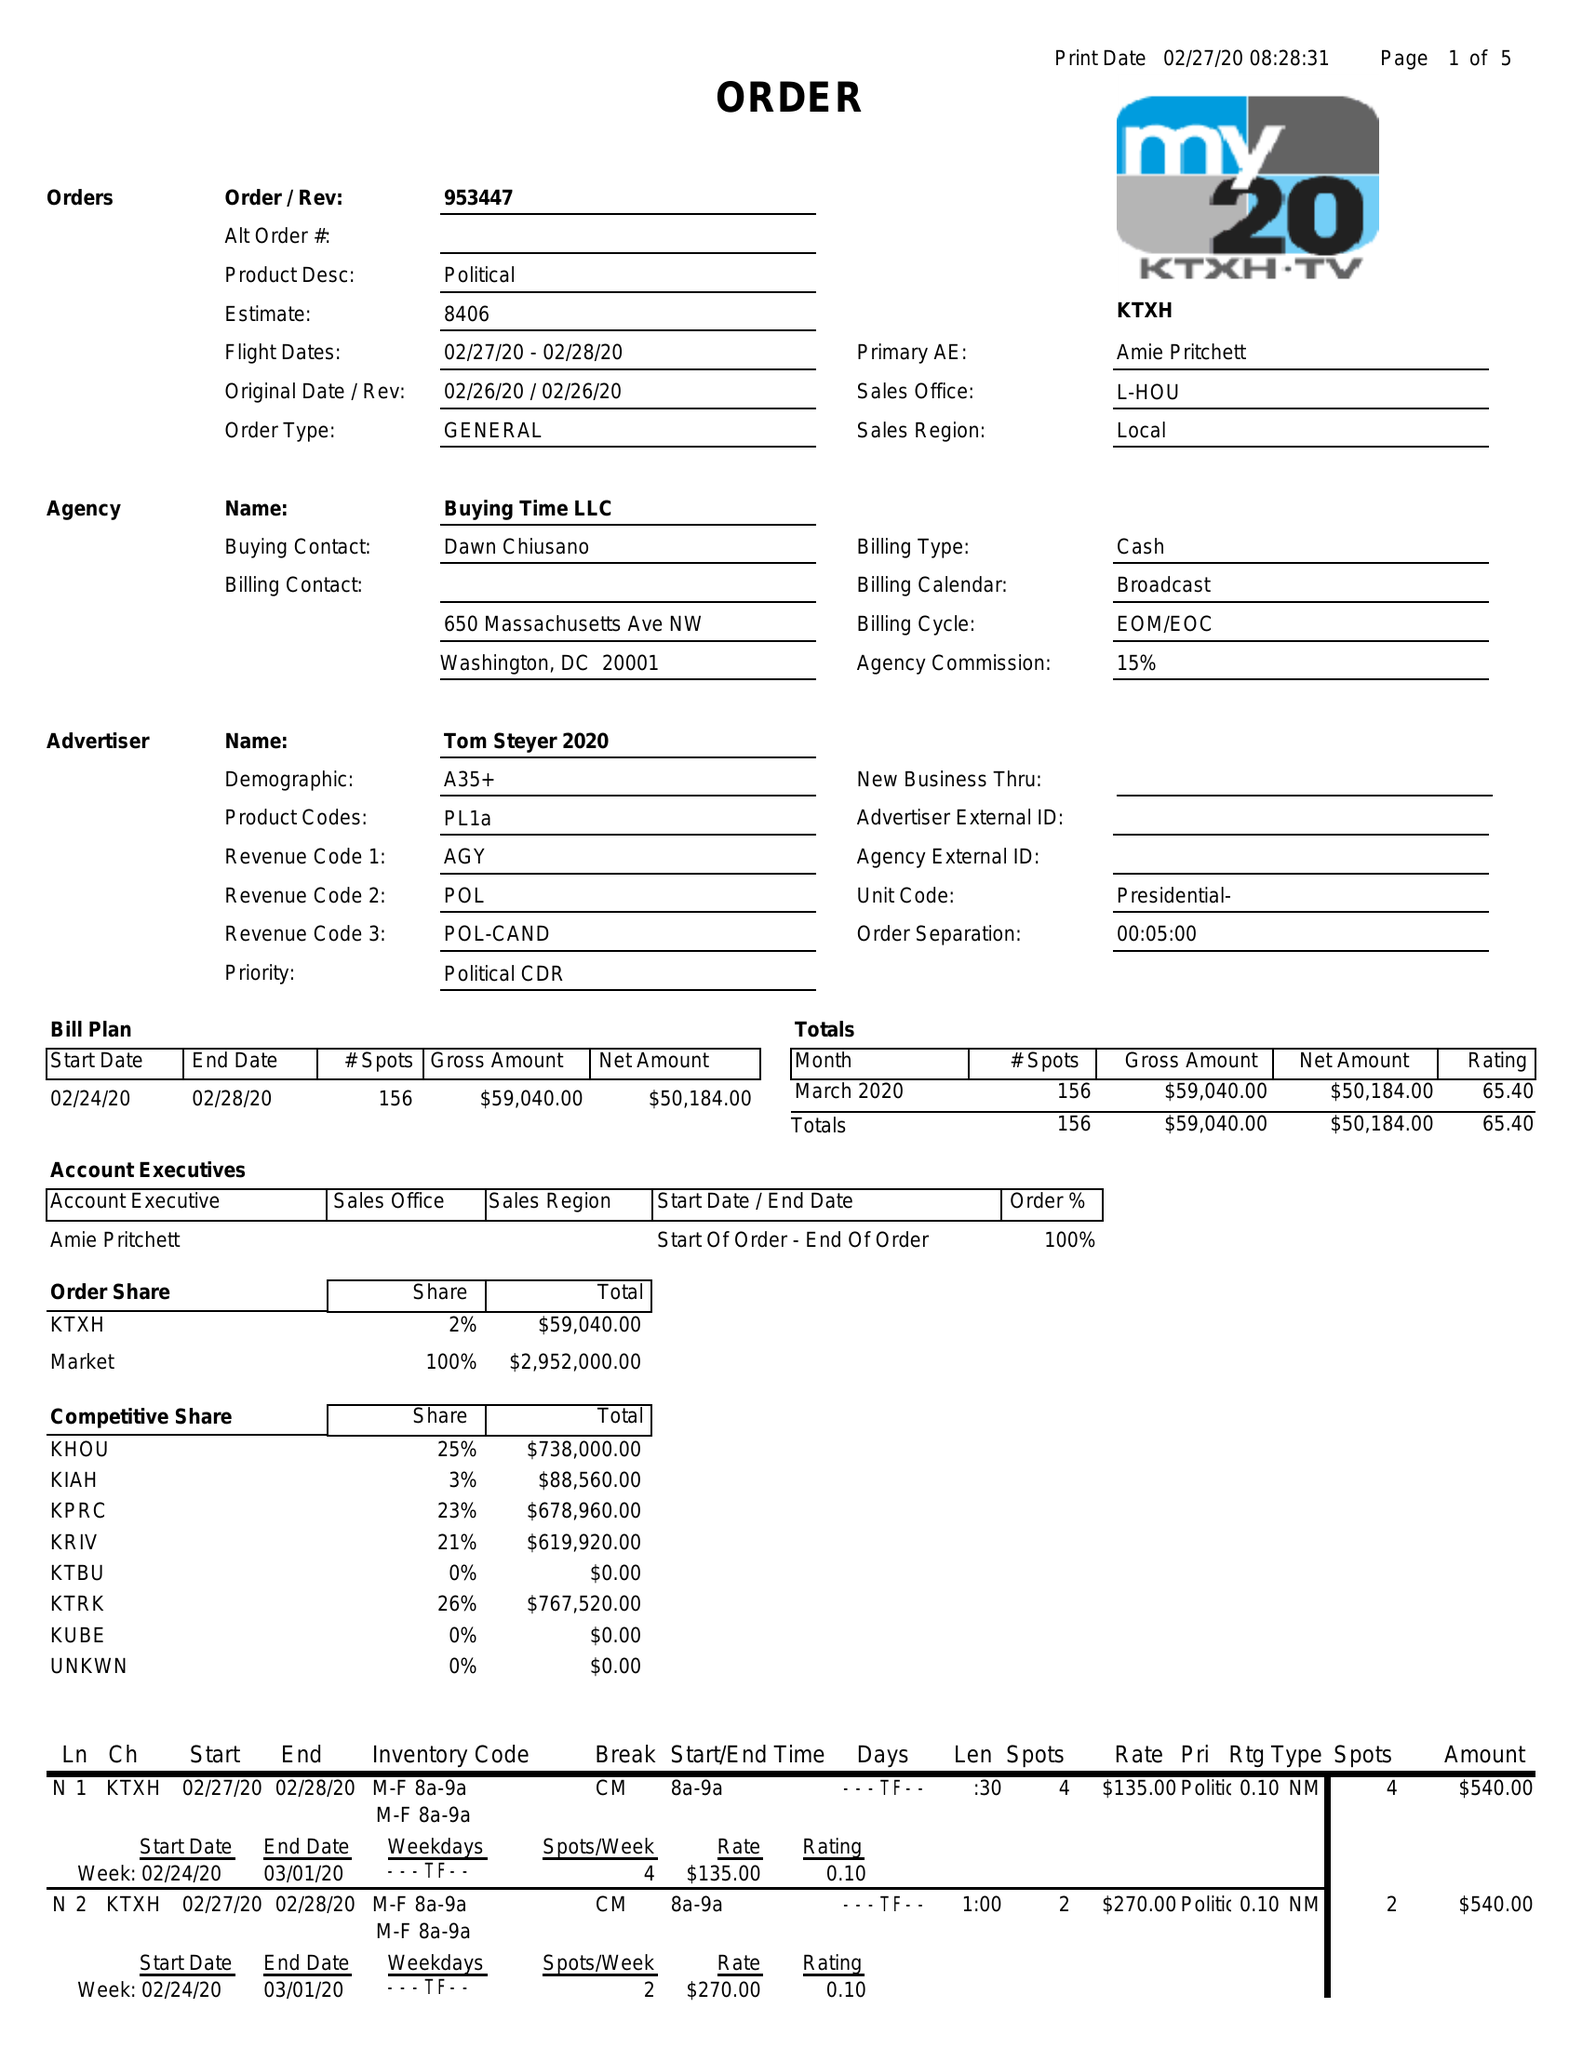What is the value for the flight_from?
Answer the question using a single word or phrase. 02/27/20 